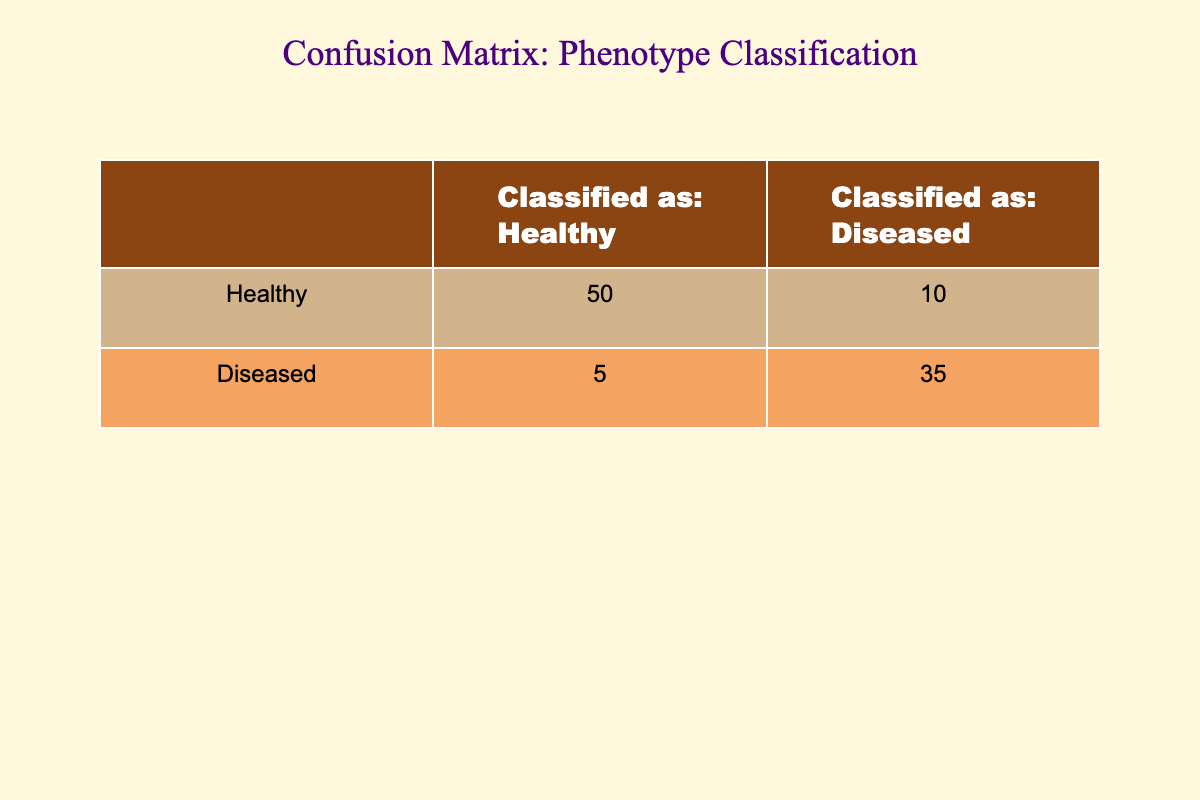What is the total number of healthy individuals classified in the experiment? To find the total number of healthy individuals classified, we need to look at the values under the "Classified as: Healthy" column. There are 50 healthy individuals correctly classified as healthy and 5 incorrectly classified as diseased. Therefore, the total is 50 + 5, which equals 55.
Answer: 55 What is the number of diseased individuals misclassified as healthy? The number of diseased individuals misclassified as healthy can be found directly in the table. Under the "Classified as: Healthy" column, there are 5 individuals who were classified as healthy but were actually diseased.
Answer: 5 Is the number of healthy individuals classified correctly greater than the number of diseased individuals classified correctly? To answer this, we compare the values in the "Classified as: Healthy" row and the "Classified as: Diseased" row. There are 50 healthy individuals classified correctly, and 35 diseased individuals classified correctly. Since 50 is greater than 35, the statement is true.
Answer: Yes What is the total number of misclassifications in the experiment? To find the total number of misclassifications, we add the number of healthy individuals misclassified as diseased (10) to the number of diseased individuals misclassified as healthy (5). Thus, the total number of misclassifications is 10 + 5 = 15.
Answer: 15 What percentage of healthy individuals were correctly classified? To find the percentage of healthy individuals that were correctly classified, we take the number of correctly classified healthy individuals (50) and divide it by the total number of healthy individuals (50 + 10 = 60). The calculation is (50/60) * 100, equaling approximately 83.33%.
Answer: 83.33% What is the difference between the number of correctly classified diseased individuals and misclassified healthy individuals? We find the number of correctly classified diseased individuals (35) and subtract the number of misclassified healthy individuals (10). The calculation is 35 - 10, which results in 25.
Answer: 25 Are there more healthy individuals classified as diseased than diseased individuals classified as healthy? We compare the numbers in the respective classifications. There are 10 healthy individuals classified as diseased and 5 diseased individuals classified as healthy. Since 10 is greater than 5, the answer is yes.
Answer: Yes What is the total number of individuals classified as healthy? To find the total number of individuals classified as healthy, we sum the values from the "Classified as: Healthy" column, which includes healthy individuals classified correctly (50) and those misclassified as healthy (5). The total is 50 + 5 = 55.
Answer: 55 